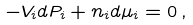Convert formula to latex. <formula><loc_0><loc_0><loc_500><loc_500>- V _ { i } d P _ { i } + n _ { i } d \mu _ { i } = 0 \, ,</formula> 